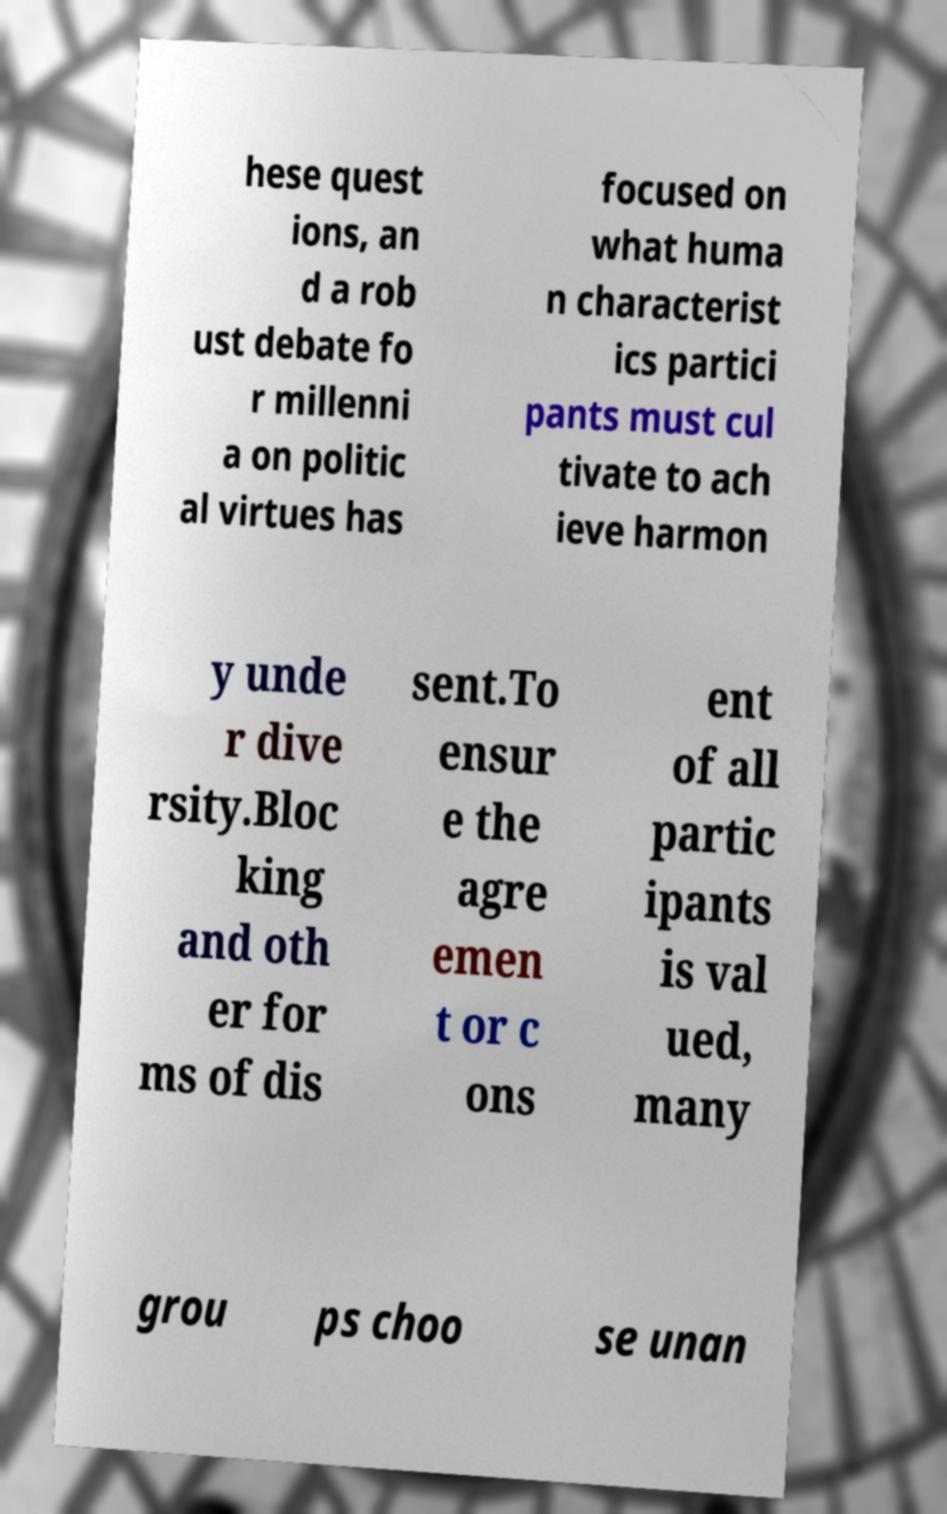Can you read and provide the text displayed in the image?This photo seems to have some interesting text. Can you extract and type it out for me? hese quest ions, an d a rob ust debate fo r millenni a on politic al virtues has focused on what huma n characterist ics partici pants must cul tivate to ach ieve harmon y unde r dive rsity.Bloc king and oth er for ms of dis sent.To ensur e the agre emen t or c ons ent of all partic ipants is val ued, many grou ps choo se unan 